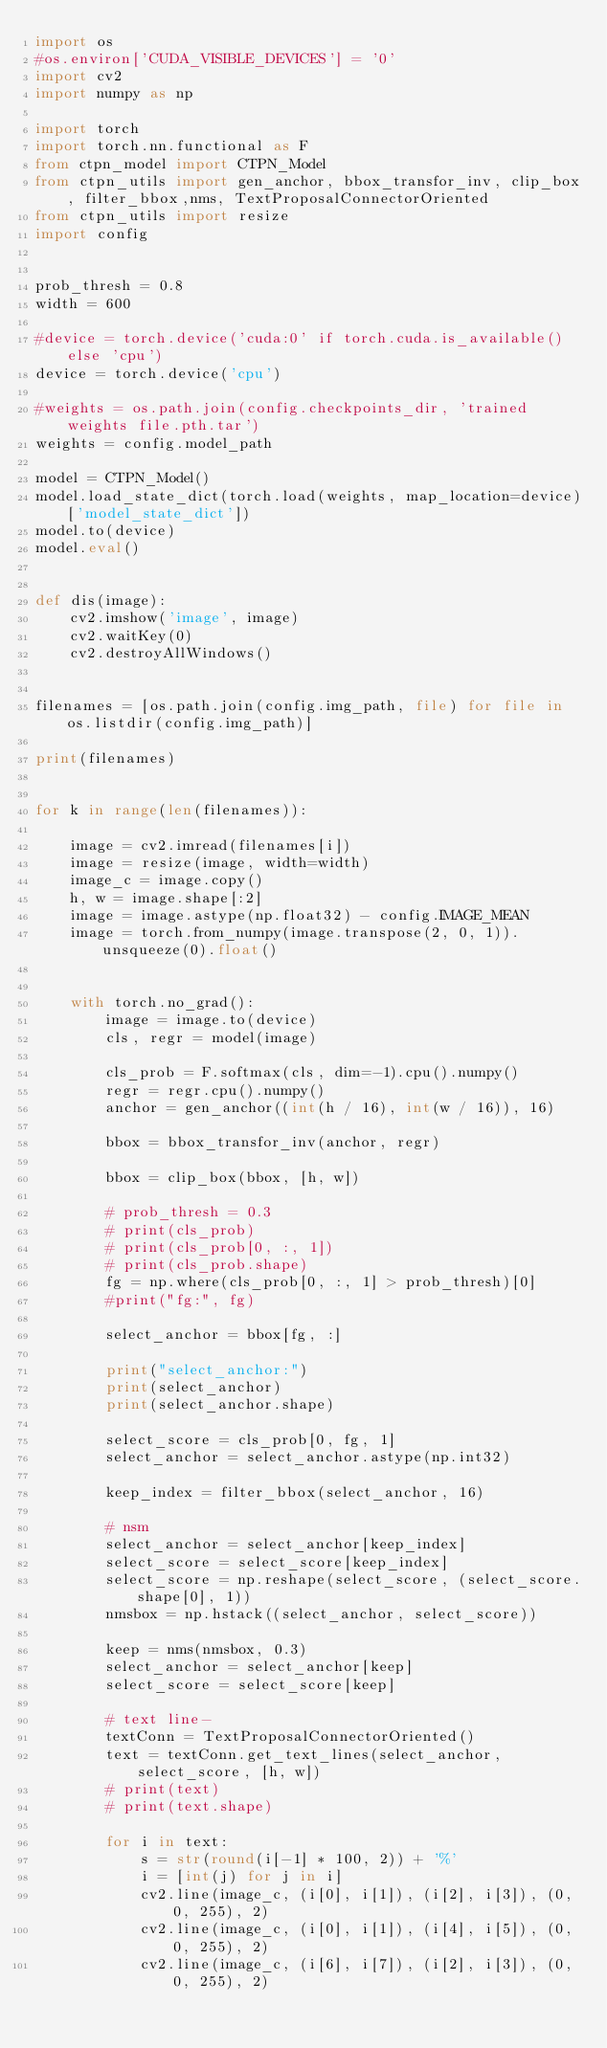Convert code to text. <code><loc_0><loc_0><loc_500><loc_500><_Python_>import os
#os.environ['CUDA_VISIBLE_DEVICES'] = '0'
import cv2
import numpy as np

import torch
import torch.nn.functional as F
from ctpn_model import CTPN_Model
from ctpn_utils import gen_anchor, bbox_transfor_inv, clip_box, filter_bbox,nms, TextProposalConnectorOriented
from ctpn_utils import resize
import config


prob_thresh = 0.8
width = 600

#device = torch.device('cuda:0' if torch.cuda.is_available() else 'cpu')
device = torch.device('cpu')

#weights = os.path.join(config.checkpoints_dir, 'trained weights file.pth.tar')
weights = config.model_path

model = CTPN_Model()
model.load_state_dict(torch.load(weights, map_location=device)['model_state_dict'])
model.to(device)
model.eval()


def dis(image):
    cv2.imshow('image', image)
    cv2.waitKey(0)
    cv2.destroyAllWindows()


filenames = [os.path.join(config.img_path, file) for file in os.listdir(config.img_path)]

print(filenames)


for k in range(len(filenames)):

    image = cv2.imread(filenames[i])
    image = resize(image, width=width)
    image_c = image.copy()
    h, w = image.shape[:2]
    image = image.astype(np.float32) - config.IMAGE_MEAN
    image = torch.from_numpy(image.transpose(2, 0, 1)).unsqueeze(0).float()


    with torch.no_grad():
        image = image.to(device)
        cls, regr = model(image)

        cls_prob = F.softmax(cls, dim=-1).cpu().numpy()
        regr = regr.cpu().numpy()
        anchor = gen_anchor((int(h / 16), int(w / 16)), 16)

        bbox = bbox_transfor_inv(anchor, regr)

        bbox = clip_box(bbox, [h, w])

        # prob_thresh = 0.3
        # print(cls_prob)
        # print(cls_prob[0, :, 1])
        # print(cls_prob.shape)
        fg = np.where(cls_prob[0, :, 1] > prob_thresh)[0]
        #print("fg:", fg)

        select_anchor = bbox[fg, :]

        print("select_anchor:")
        print(select_anchor)
        print(select_anchor.shape)

        select_score = cls_prob[0, fg, 1]
        select_anchor = select_anchor.astype(np.int32)

        keep_index = filter_bbox(select_anchor, 16)

        # nsm
        select_anchor = select_anchor[keep_index]
        select_score = select_score[keep_index]
        select_score = np.reshape(select_score, (select_score.shape[0], 1))
        nmsbox = np.hstack((select_anchor, select_score))
        
        keep = nms(nmsbox, 0.3)
        select_anchor = select_anchor[keep]
        select_score = select_score[keep]

        # text line-
        textConn = TextProposalConnectorOriented()
        text = textConn.get_text_lines(select_anchor, select_score, [h, w])
        # print(text)
        # print(text.shape)

        for i in text:
            s = str(round(i[-1] * 100, 2)) + '%'
            i = [int(j) for j in i]
            cv2.line(image_c, (i[0], i[1]), (i[2], i[3]), (0, 0, 255), 2)
            cv2.line(image_c, (i[0], i[1]), (i[4], i[5]), (0, 0, 255), 2)
            cv2.line(image_c, (i[6], i[7]), (i[2], i[3]), (0, 0, 255), 2)</code> 